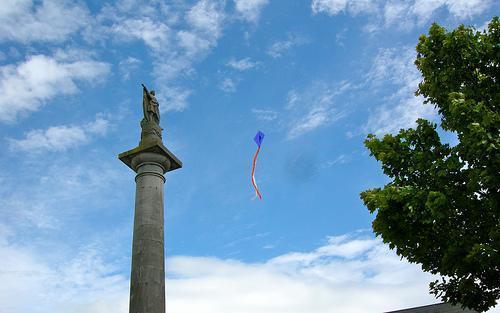How many kites are in the picture?
Give a very brief answer. 1. 